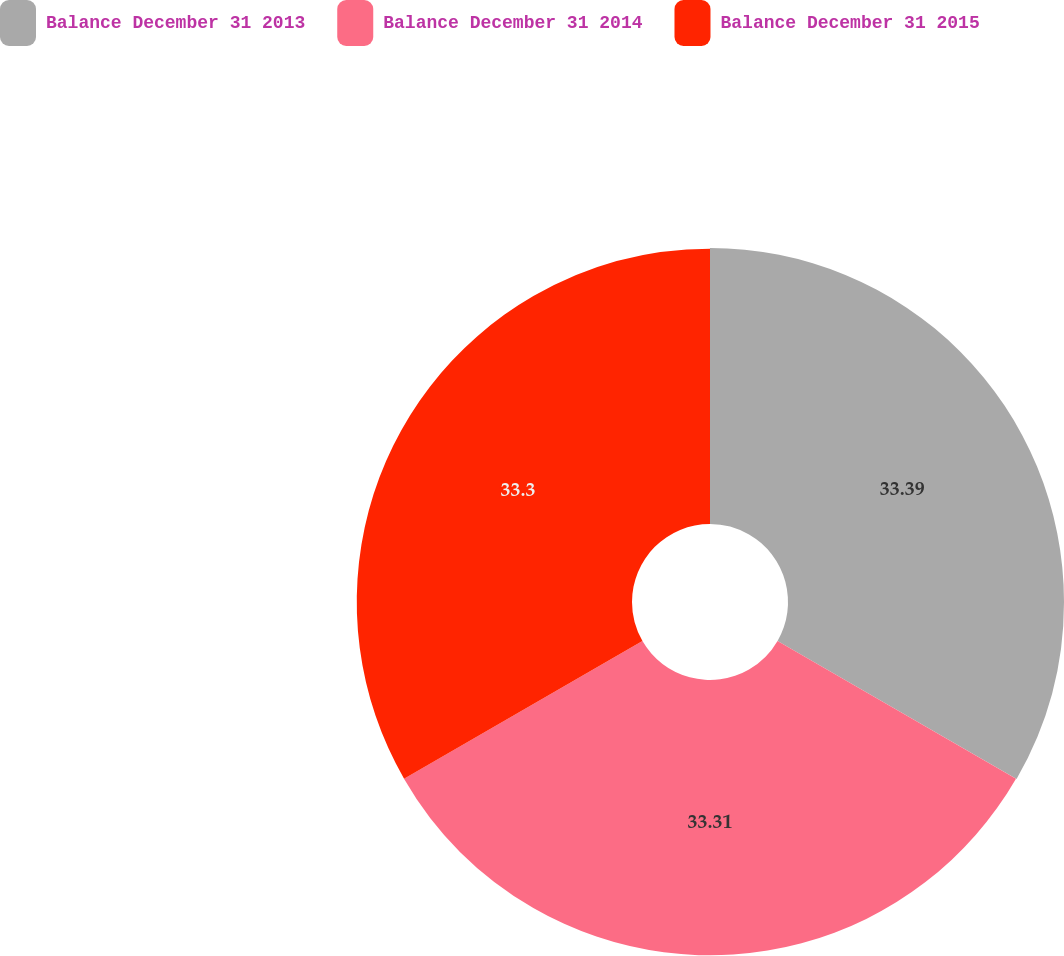Convert chart to OTSL. <chart><loc_0><loc_0><loc_500><loc_500><pie_chart><fcel>Balance December 31 2013<fcel>Balance December 31 2014<fcel>Balance December 31 2015<nl><fcel>33.39%<fcel>33.31%<fcel>33.3%<nl></chart> 